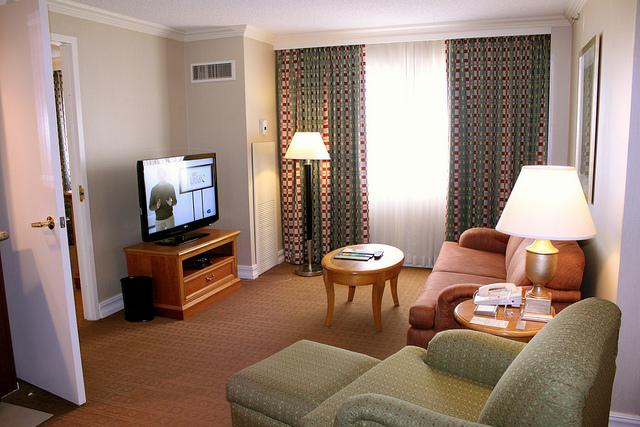What is the appliance in this room used for? watching 